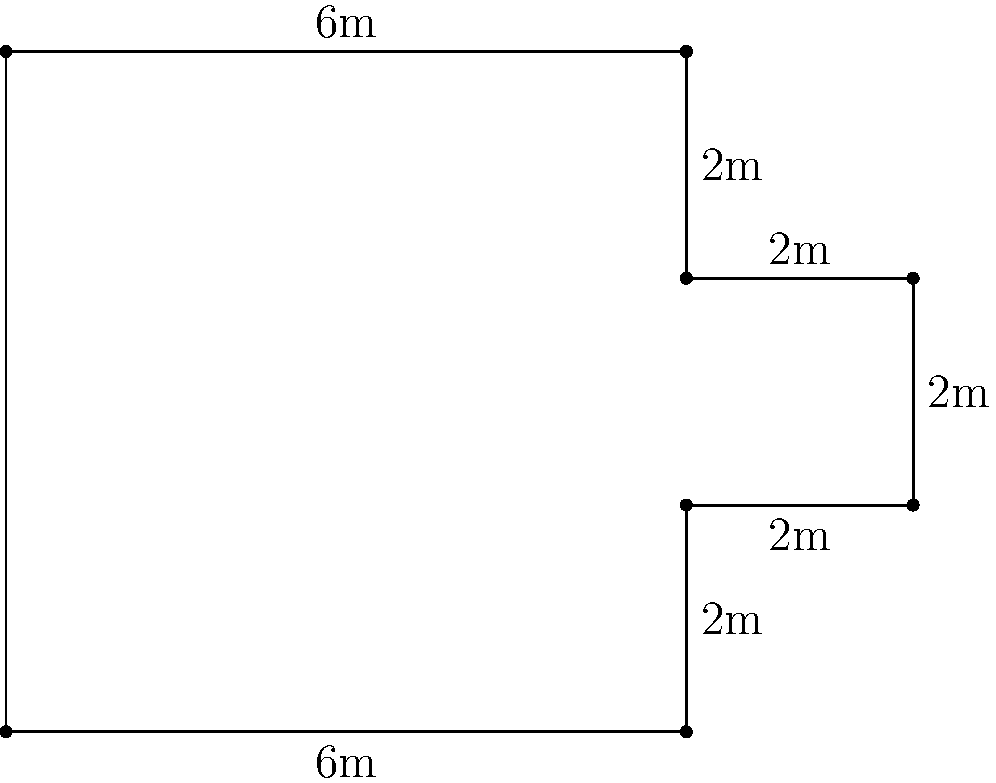Rozzi's upcoming concert features a uniquely designed stage that resembles the shape shown in the diagram. If each small square represents 1 square meter, what is the perimeter of the stage in meters? Let's calculate the perimeter by following the outline of the stage:

1. Bottom edge: 6m
2. Right side, first segment: 2m
3. Right side, small extension: 2m
4. Right side, second segment: 2m
5. Top right, small indentation: 2m
6. Top edge: 6m
7. Left side: 6m

To find the total perimeter, we sum up all these lengths:

$$\text{Perimeter} = 6 + 2 + 2 + 2 + 2 + 6 + 6 = 26\text{ m}$$

Therefore, the perimeter of Rozzi's concert stage is 26 meters.
Answer: 26 m 